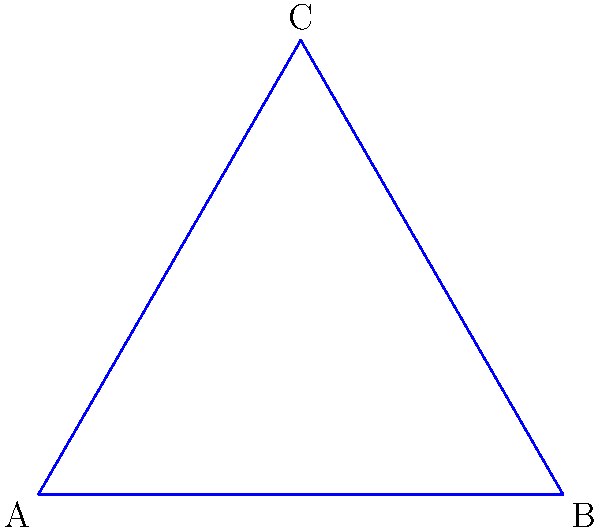As a contractor familiar with traditional insulating materials, you're tasked with designing a triangular attic space. You draw a triangle on a flat surface and another on a hyperbolic plane. How does the sum of the interior angles of the hyperbolic triangle compare to the sum of the interior angles of the Euclidean triangle? To understand the difference between triangles on a flat surface (Euclidean geometry) and a hyperbolic plane, let's break it down step-by-step:

1. Euclidean Triangle:
   - In Euclidean geometry (flat surface), the sum of the interior angles of a triangle is always 180°.
   - This is represented by the blue triangle in the diagram.

2. Hyperbolic Triangle:
   - In hyperbolic geometry, the sum of the interior angles of a triangle is always less than 180°.
   - This is represented by the red triangle in the Poincaré disk model shown in the diagram.

3. Key Differences:
   - In Euclidean geometry, parallel lines remain equidistant and never meet.
   - In hyperbolic geometry, parallel lines diverge from each other.
   - This divergence causes the angles in a hyperbolic triangle to be "smaller" than in a Euclidean triangle.

4. Angle Deficit:
   - The difference between 180° and the sum of the angles in a hyperbolic triangle is called the angle deficit.
   - The larger the hyperbolic triangle, the greater the angle deficit.

5. Practical Implications:
   - While not directly applicable to traditional insulation, understanding these geometric principles can be useful in specialized construction projects or when working with non-standard spaces.

In summary, the sum of the interior angles of a triangle on a hyperbolic plane is always less than the sum of the interior angles of a triangle on a flat (Euclidean) surface.
Answer: Less than 180° 